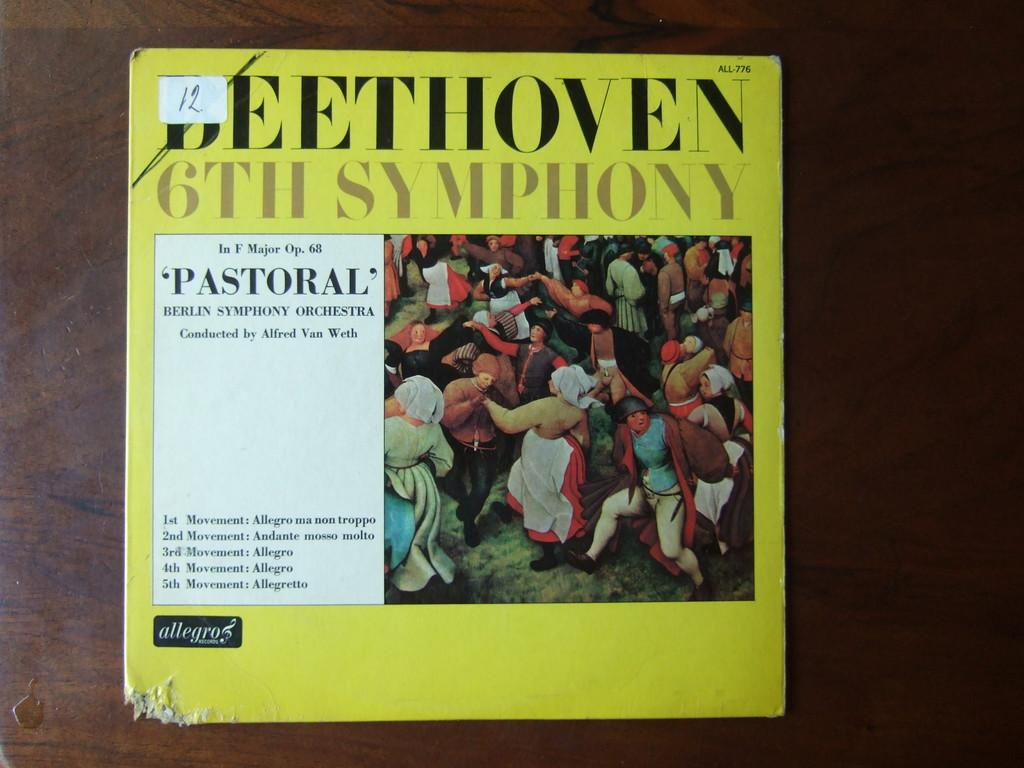<image>
Write a terse but informative summary of the picture. A yellow CD cover of Beethoven 6th symphony. 